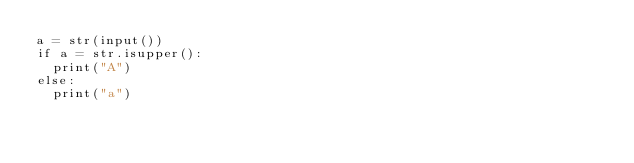Convert code to text. <code><loc_0><loc_0><loc_500><loc_500><_Python_>a = str(input())
if a = str.isupper():
  print("A")
else:
  print("a")</code> 